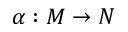Convert formula to latex. <formula><loc_0><loc_0><loc_500><loc_500>\alpha \colon M \rightarrow N</formula> 